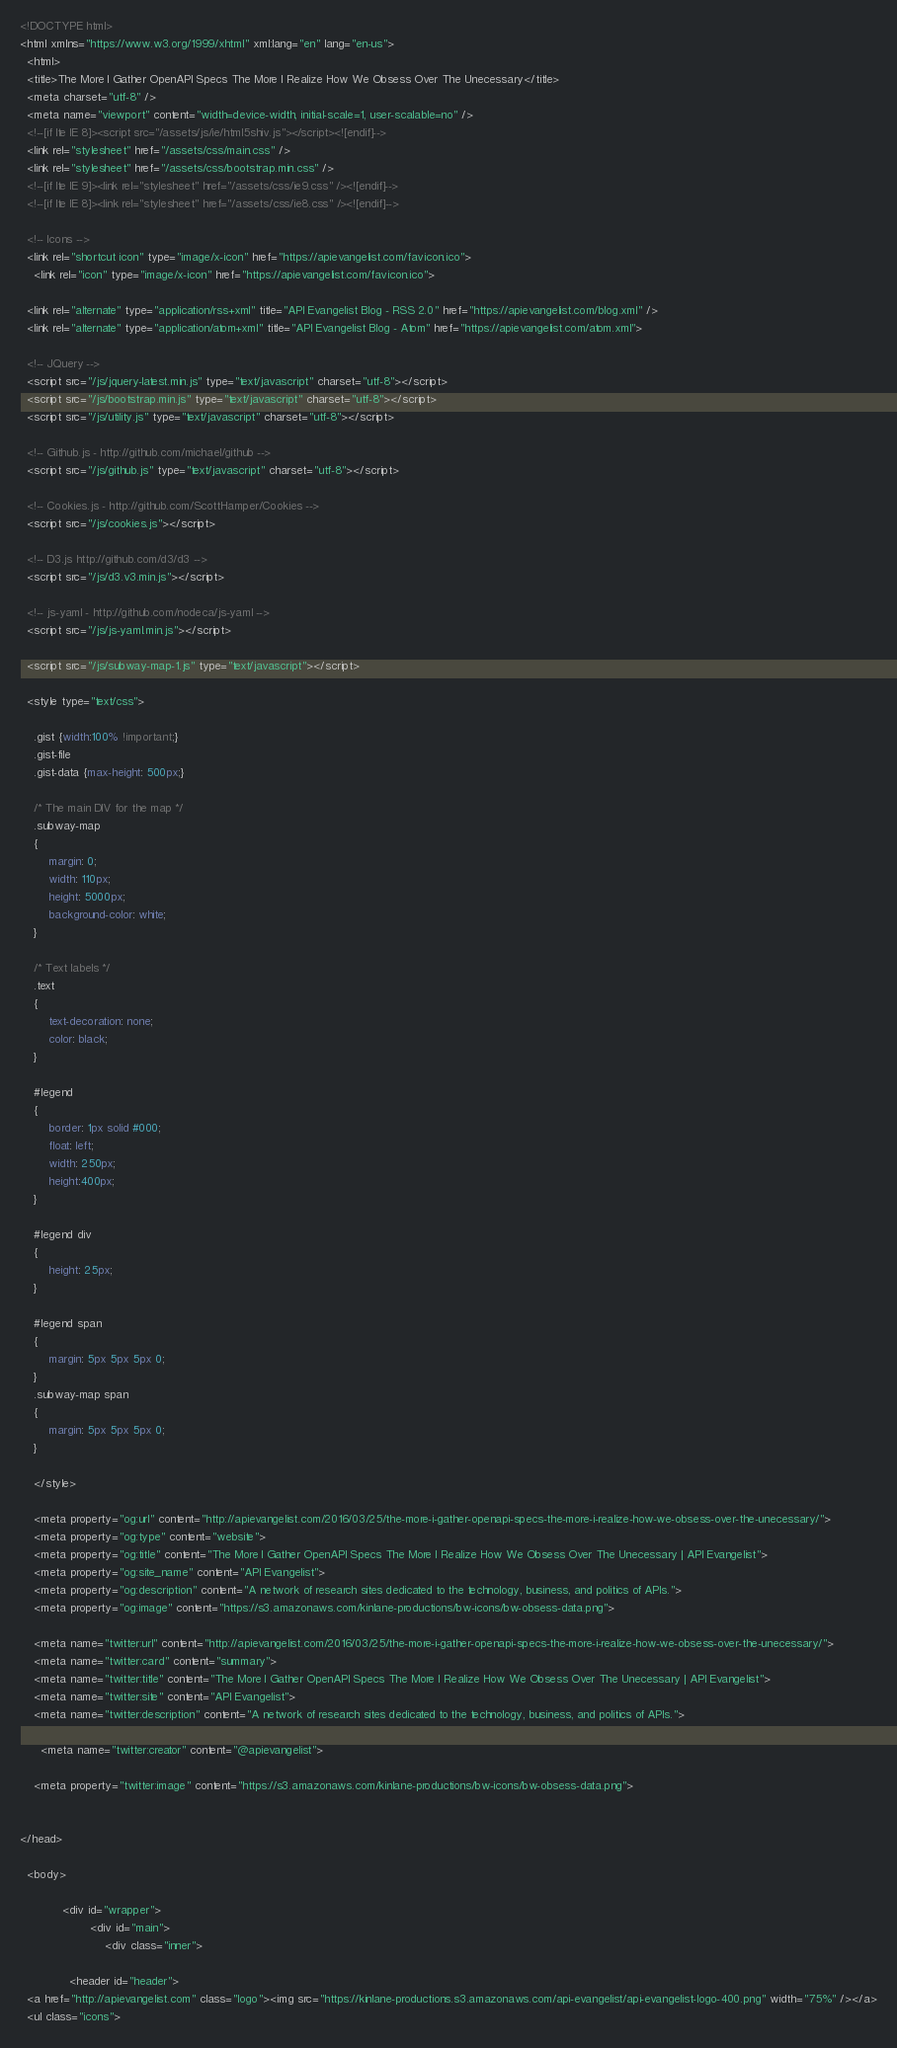<code> <loc_0><loc_0><loc_500><loc_500><_HTML_><!DOCTYPE html>
<html xmlns="https://www.w3.org/1999/xhtml" xml:lang="en" lang="en-us">
  <html>
  <title>The More I Gather OpenAPI Specs The More I Realize How We Obsess Over The Unecessary</title>
  <meta charset="utf-8" />
  <meta name="viewport" content="width=device-width, initial-scale=1, user-scalable=no" />
  <!--[if lte IE 8]><script src="/assets/js/ie/html5shiv.js"></script><![endif]-->
  <link rel="stylesheet" href="/assets/css/main.css" />
  <link rel="stylesheet" href="/assets/css/bootstrap.min.css" />
  <!--[if lte IE 9]><link rel="stylesheet" href="/assets/css/ie9.css" /><![endif]-->
  <!--[if lte IE 8]><link rel="stylesheet" href="/assets/css/ie8.css" /><![endif]-->

  <!-- Icons -->
  <link rel="shortcut icon" type="image/x-icon" href="https://apievangelist.com/favicon.ico">
	<link rel="icon" type="image/x-icon" href="https://apievangelist.com/favicon.ico">

  <link rel="alternate" type="application/rss+xml" title="API Evangelist Blog - RSS 2.0" href="https://apievangelist.com/blog.xml" />
  <link rel="alternate" type="application/atom+xml" title="API Evangelist Blog - Atom" href="https://apievangelist.com/atom.xml">

  <!-- JQuery -->
  <script src="/js/jquery-latest.min.js" type="text/javascript" charset="utf-8"></script>
  <script src="/js/bootstrap.min.js" type="text/javascript" charset="utf-8"></script>
  <script src="/js/utility.js" type="text/javascript" charset="utf-8"></script>

  <!-- Github.js - http://github.com/michael/github -->
  <script src="/js/github.js" type="text/javascript" charset="utf-8"></script>

  <!-- Cookies.js - http://github.com/ScottHamper/Cookies -->
  <script src="/js/cookies.js"></script>

  <!-- D3.js http://github.com/d3/d3 -->
  <script src="/js/d3.v3.min.js"></script>

  <!-- js-yaml - http://github.com/nodeca/js-yaml -->
  <script src="/js/js-yaml.min.js"></script>

  <script src="/js/subway-map-1.js" type="text/javascript"></script>

  <style type="text/css">

    .gist {width:100% !important;}
    .gist-file
    .gist-data {max-height: 500px;}

    /* The main DIV for the map */
    .subway-map
    {
        margin: 0;
        width: 110px;
        height: 5000px;
        background-color: white;
    }

    /* Text labels */
    .text
    {
        text-decoration: none;
        color: black;
    }

    #legend
    {
    	border: 1px solid #000;
        float: left;
        width: 250px;
        height:400px;
    }

    #legend div
    {
        height: 25px;
    }

    #legend span
    {
        margin: 5px 5px 5px 0;
    }
    .subway-map span
    {
        margin: 5px 5px 5px 0;
    }

    </style>

    <meta property="og:url" content="http://apievangelist.com/2016/03/25/the-more-i-gather-openapi-specs-the-more-i-realize-how-we-obsess-over-the-unecessary/">
    <meta property="og:type" content="website">
    <meta property="og:title" content="The More I Gather OpenAPI Specs The More I Realize How We Obsess Over The Unecessary | API Evangelist">
    <meta property="og:site_name" content="API Evangelist">
    <meta property="og:description" content="A network of research sites dedicated to the technology, business, and politics of APIs.">
    <meta property="og:image" content="https://s3.amazonaws.com/kinlane-productions/bw-icons/bw-obsess-data.png">

    <meta name="twitter:url" content="http://apievangelist.com/2016/03/25/the-more-i-gather-openapi-specs-the-more-i-realize-how-we-obsess-over-the-unecessary/">
    <meta name="twitter:card" content="summary">
    <meta name="twitter:title" content="The More I Gather OpenAPI Specs The More I Realize How We Obsess Over The Unecessary | API Evangelist">
    <meta name="twitter:site" content="API Evangelist">
    <meta name="twitter:description" content="A network of research sites dedicated to the technology, business, and politics of APIs.">
    
      <meta name="twitter:creator" content="@apievangelist">
    
    <meta property="twitter:image" content="https://s3.amazonaws.com/kinlane-productions/bw-icons/bw-obsess-data.png">


</head>

  <body>

			<div id="wrapper">
					<div id="main">
						<div class="inner">

              <header id="header">
  <a href="http://apievangelist.com" class="logo"><img src="https://kinlane-productions.s3.amazonaws.com/api-evangelist/api-evangelist-logo-400.png" width="75%" /></a>
  <ul class="icons"></code> 